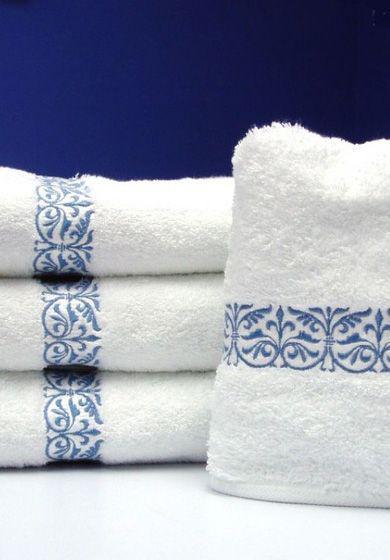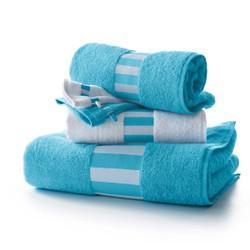The first image is the image on the left, the second image is the image on the right. Considering the images on both sides, is "There are four towels on the left and three towels on the right, all folded neatly" valid? Answer yes or no. Yes. The first image is the image on the left, the second image is the image on the right. Considering the images on both sides, is "A stack of three or more towels has folded washcloths on top." valid? Answer yes or no. No. 